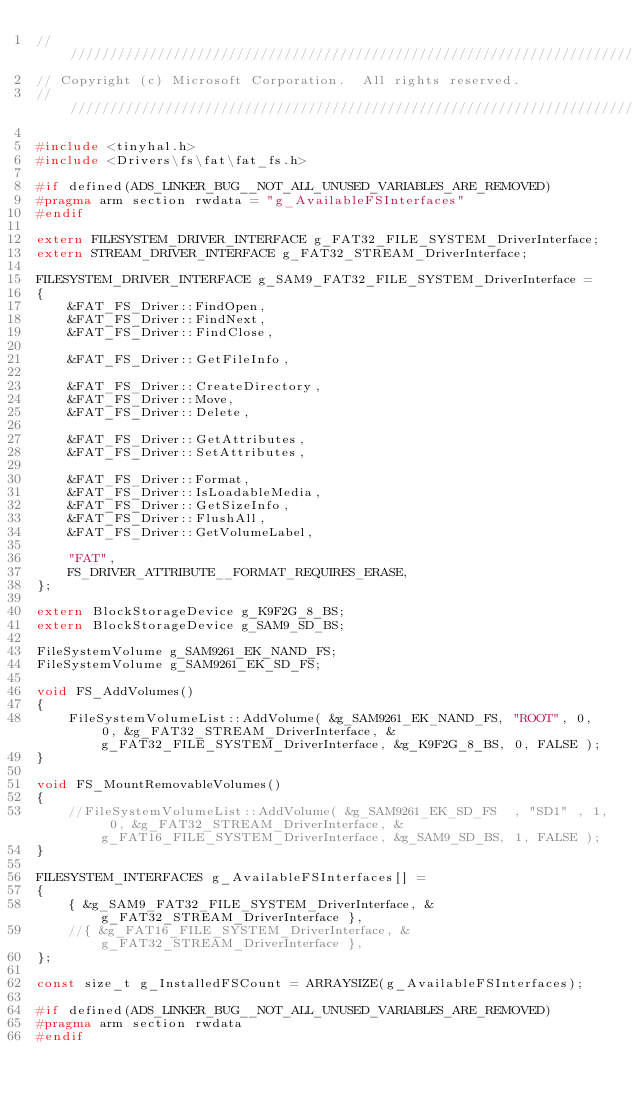Convert code to text. <code><loc_0><loc_0><loc_500><loc_500><_C++_>////////////////////////////////////////////////////////////////////////////////////////////////////////////////////////////////////////////////////////////////////////////////////////////////////////
// Copyright (c) Microsoft Corporation.  All rights reserved.
////////////////////////////////////////////////////////////////////////////////////////////////////////////////////////////////////////////////////////////////////////////////////////////////////////

#include <tinyhal.h>
#include <Drivers\fs\fat\fat_fs.h>

#if defined(ADS_LINKER_BUG__NOT_ALL_UNUSED_VARIABLES_ARE_REMOVED)
#pragma arm section rwdata = "g_AvailableFSInterfaces"
#endif

extern FILESYSTEM_DRIVER_INTERFACE g_FAT32_FILE_SYSTEM_DriverInterface;
extern STREAM_DRIVER_INTERFACE g_FAT32_STREAM_DriverInterface;

FILESYSTEM_DRIVER_INTERFACE g_SAM9_FAT32_FILE_SYSTEM_DriverInterface = 
{    
    &FAT_FS_Driver::FindOpen,
    &FAT_FS_Driver::FindNext,
    &FAT_FS_Driver::FindClose,

    &FAT_FS_Driver::GetFileInfo,

    &FAT_FS_Driver::CreateDirectory,
    &FAT_FS_Driver::Move,
    &FAT_FS_Driver::Delete,

    &FAT_FS_Driver::GetAttributes,
    &FAT_FS_Driver::SetAttributes,    

    &FAT_FS_Driver::Format,
    &FAT_FS_Driver::IsLoadableMedia, 
    &FAT_FS_Driver::GetSizeInfo,
    &FAT_FS_Driver::FlushAll,
    &FAT_FS_Driver::GetVolumeLabel,

    "FAT",
    FS_DRIVER_ATTRIBUTE__FORMAT_REQUIRES_ERASE,
};

extern BlockStorageDevice g_K9F2G_8_BS;
extern BlockStorageDevice g_SAM9_SD_BS;

FileSystemVolume g_SAM9261_EK_NAND_FS;
FileSystemVolume g_SAM9261_EK_SD_FS;

void FS_AddVolumes()
{
    FileSystemVolumeList::AddVolume( &g_SAM9261_EK_NAND_FS, "ROOT", 0, 0, &g_FAT32_STREAM_DriverInterface, &g_FAT32_FILE_SYSTEM_DriverInterface, &g_K9F2G_8_BS, 0, FALSE );
}

void FS_MountRemovableVolumes()
{
    //FileSystemVolumeList::AddVolume( &g_SAM9261_EK_SD_FS  , "SD1" , 1, 0, &g_FAT32_STREAM_DriverInterface, &g_FAT16_FILE_SYSTEM_DriverInterface, &g_SAM9_SD_BS, 1, FALSE );
}

FILESYSTEM_INTERFACES g_AvailableFSInterfaces[] =
{
    { &g_SAM9_FAT32_FILE_SYSTEM_DriverInterface, &g_FAT32_STREAM_DriverInterface },
    //{ &g_FAT16_FILE_SYSTEM_DriverInterface, &g_FAT32_STREAM_DriverInterface },
};

const size_t g_InstalledFSCount = ARRAYSIZE(g_AvailableFSInterfaces);

#if defined(ADS_LINKER_BUG__NOT_ALL_UNUSED_VARIABLES_ARE_REMOVED)
#pragma arm section rwdata
#endif
</code> 